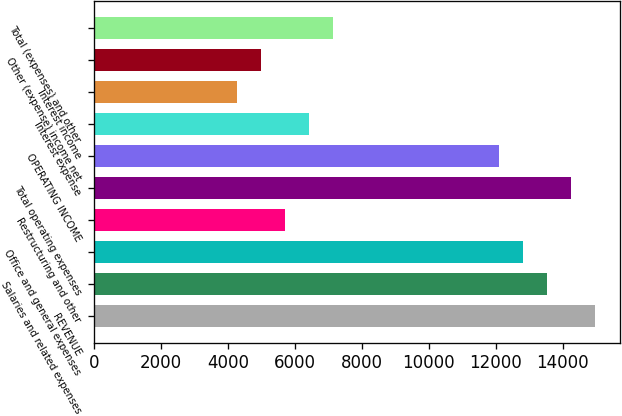Convert chart. <chart><loc_0><loc_0><loc_500><loc_500><bar_chart><fcel>REVENUE<fcel>Salaries and related expenses<fcel>Office and general expenses<fcel>Restructuring and other<fcel>Total operating expenses<fcel>OPERATING INCOME<fcel>Interest expense<fcel>Interest income<fcel>Other (expense) income net<fcel>Total (expenses) and other<nl><fcel>14956.5<fcel>13532.1<fcel>12819.9<fcel>5697.9<fcel>14244.3<fcel>12107.7<fcel>6410.1<fcel>4273.5<fcel>4985.7<fcel>7122.3<nl></chart> 